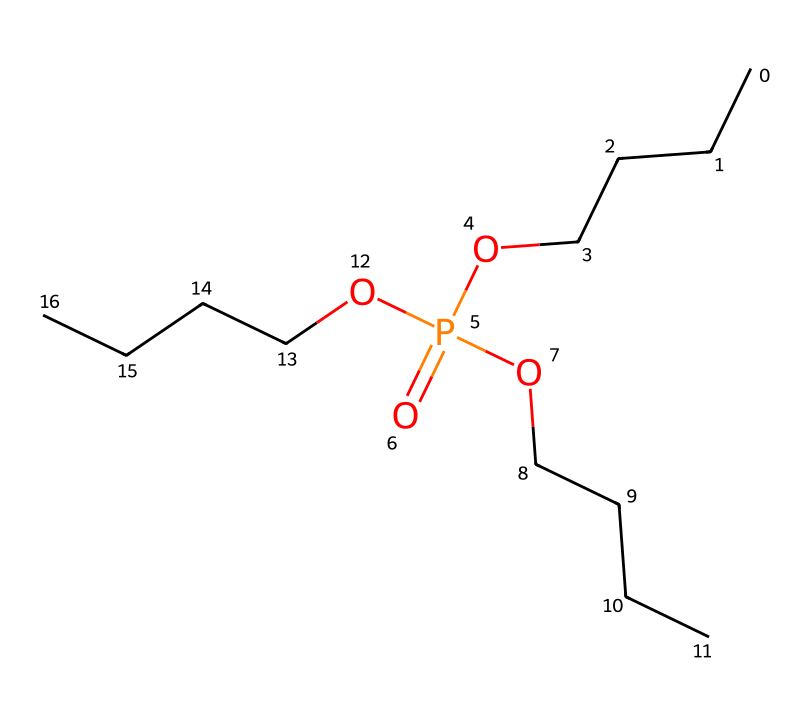What is the chemical name of this compound? The chemical structure corresponds to the SMILES representation of tributyl phosphate, which is derived from its components: three butyl groups (C4H9) connected through an inorganic phosphate group.
Answer: tributyl phosphate How many phosphorus atoms are present in this compound? The structure shows one phosphorus atom (P) present in the phosphate group, which is crucial for its classification as a phosphorus compound.
Answer: one What functional group is represented in this chemical structure? The presence of the P(=O) notation indicates a phosphate functional group, which is characteristic of phosphorus compounds. The O atoms bonded to P signify the phosphate bonds.
Answer: phosphate How many butyl groups are attached to the phosphorus atom? An analysis of the structure reveals that there are three distinct butyl groups (represented as "OCCCC") linked to the central phosphorus atom, which are typical in tributyl phosphate.
Answer: three What type of chemical bond is formed between the phosphorus atom and the oxygen atoms? The bonds between the phosphorus atom and the oxygen atoms in the phosphate functional group are covalent bonds, as phosphorus shares electrons with oxygen in these connections.
Answer: covalent bonds Why might tributyl phosphate be used as an industrial solvent? The large hydrocarbon butyl groups present contribute to its hydrophobic properties and solubility in organic solvents, making it suitable for dissolving various substances in industrial applications.
Answer: hydrophobic properties 